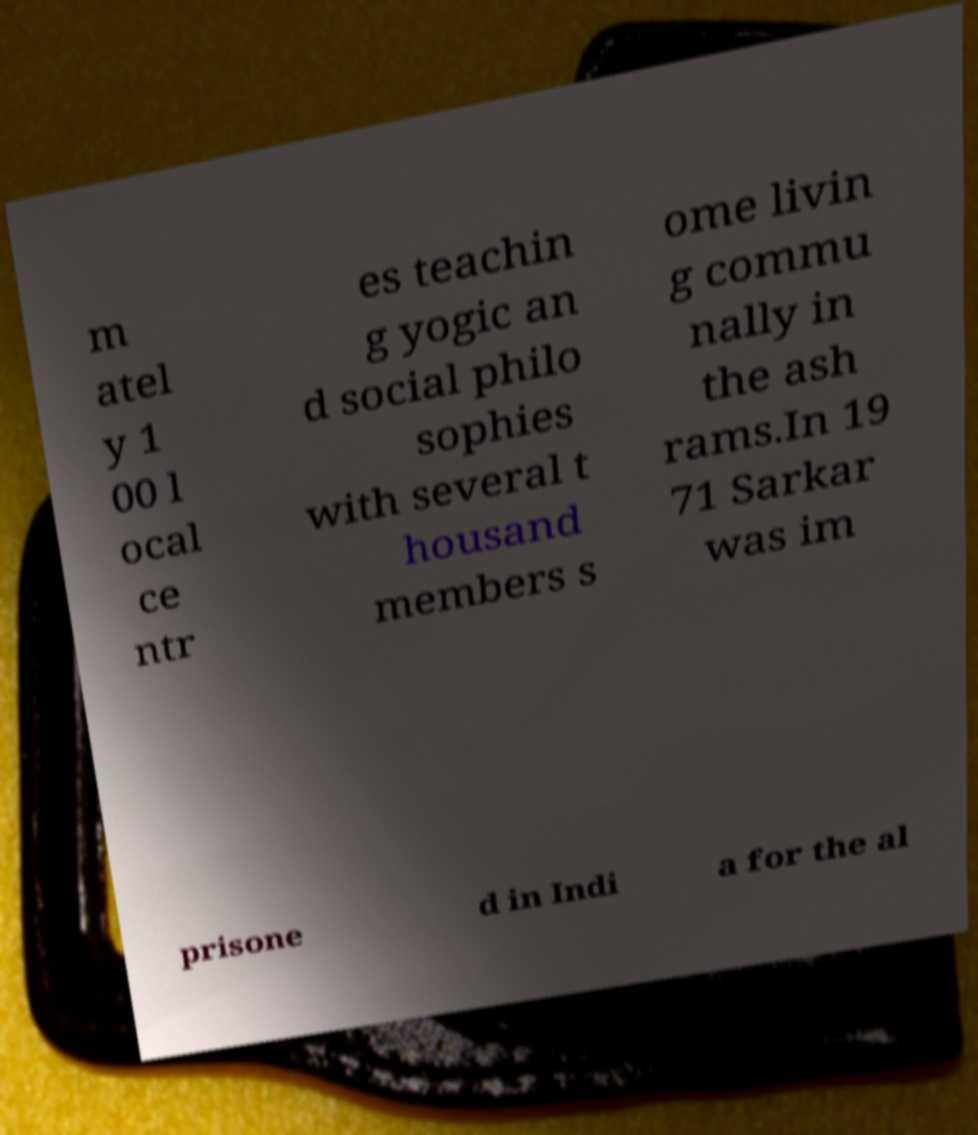Could you assist in decoding the text presented in this image and type it out clearly? m atel y 1 00 l ocal ce ntr es teachin g yogic an d social philo sophies with several t housand members s ome livin g commu nally in the ash rams.In 19 71 Sarkar was im prisone d in Indi a for the al 